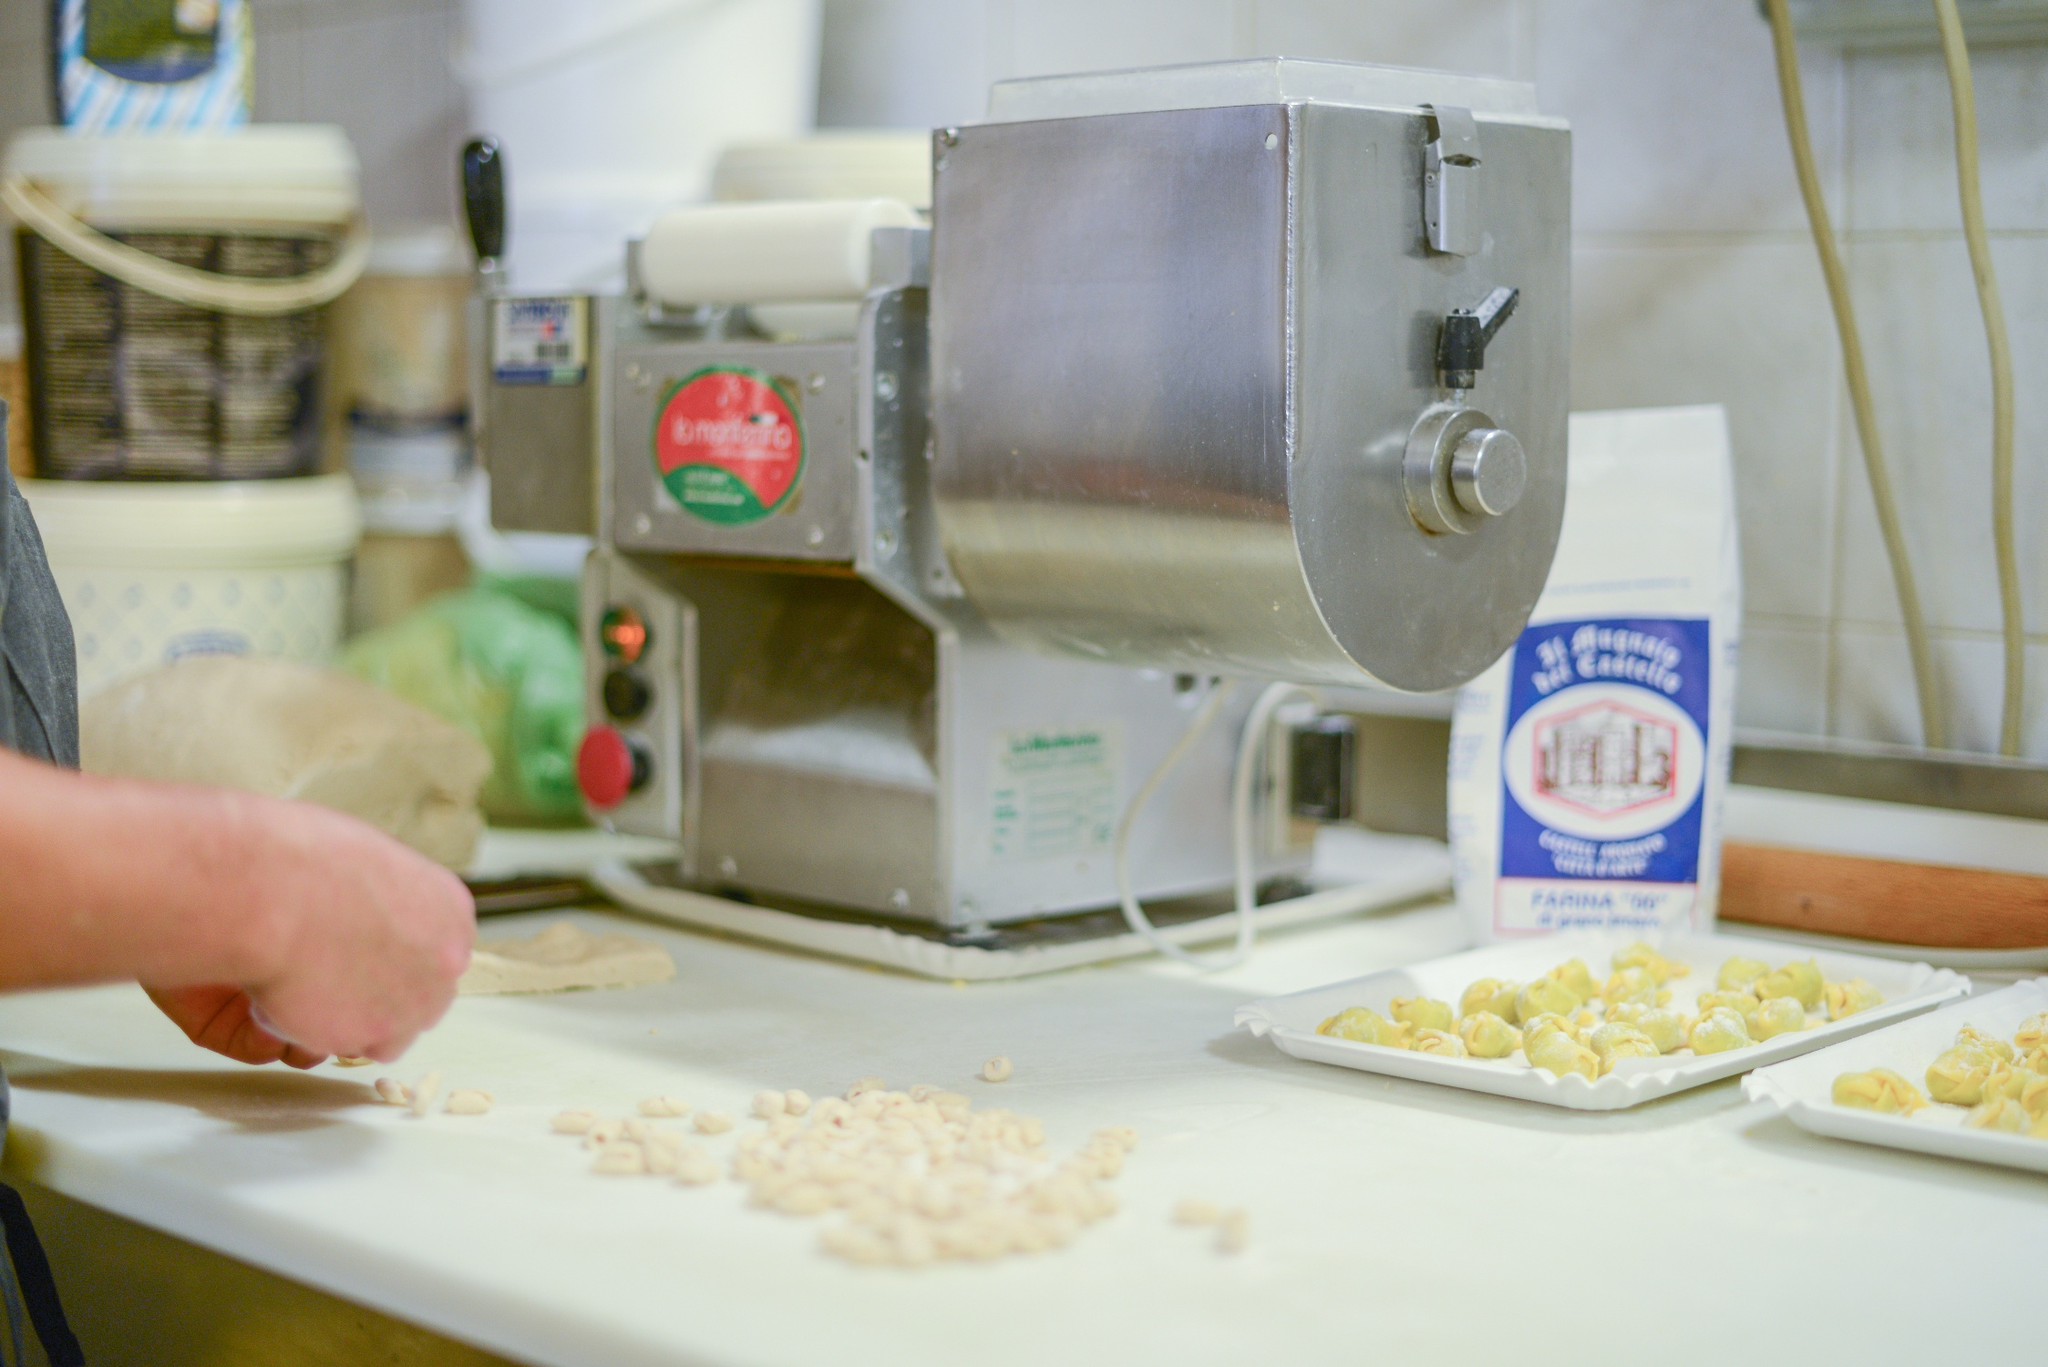Can you describe the kitchen tools and utensils? Certainly! The image prominently features a sturdy pasta machine with a sleek, metallic finish and a red 'La monferrina' label, essential for rolling and cutting pasta dough into various shapes. A white bowl with a blue rim, perfect for mixing ingredients, sits on the countertop, alongside a white bag of 'La Molisana Farina Tipo 00' flour, a staple in pasta preparation. Additionally, trays of freshly crafted pasta and a rolling mat can be seen, tools that indicate a hands-on approach to pasta making. Shelves in the background house additional kitchen items, ready to be used. Why is having '00' flour important for pasta making? '00' flour, such as the one labeled 'La Molisana Farina Tipo 00' in the image, is crucial in pasta making due to its finely milled texture. This fine grind allows for a smooth and elastic dough, which is easier to roll out and shape into various pasta forms. Its high protein content also ensures a robust dough that can withstand the mechanical processing in pasta machines while delivering the desired tenderness and bite in the final product. 